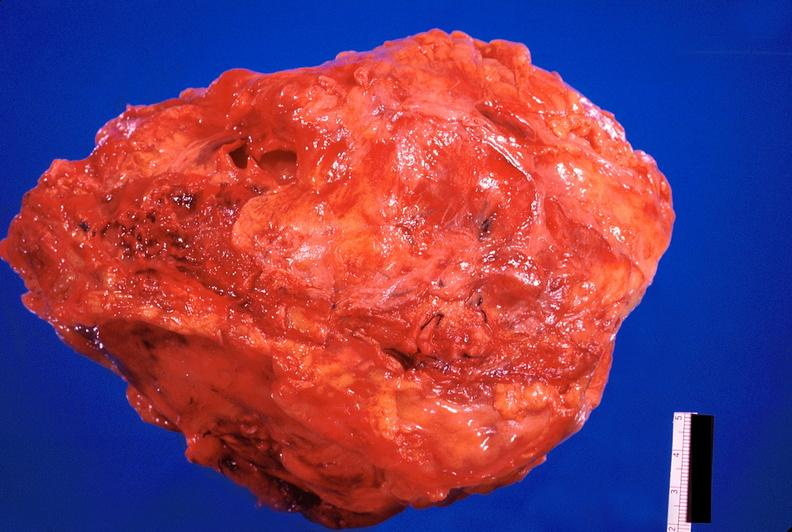s cardiovascular present?
Answer the question using a single word or phrase. Yes 